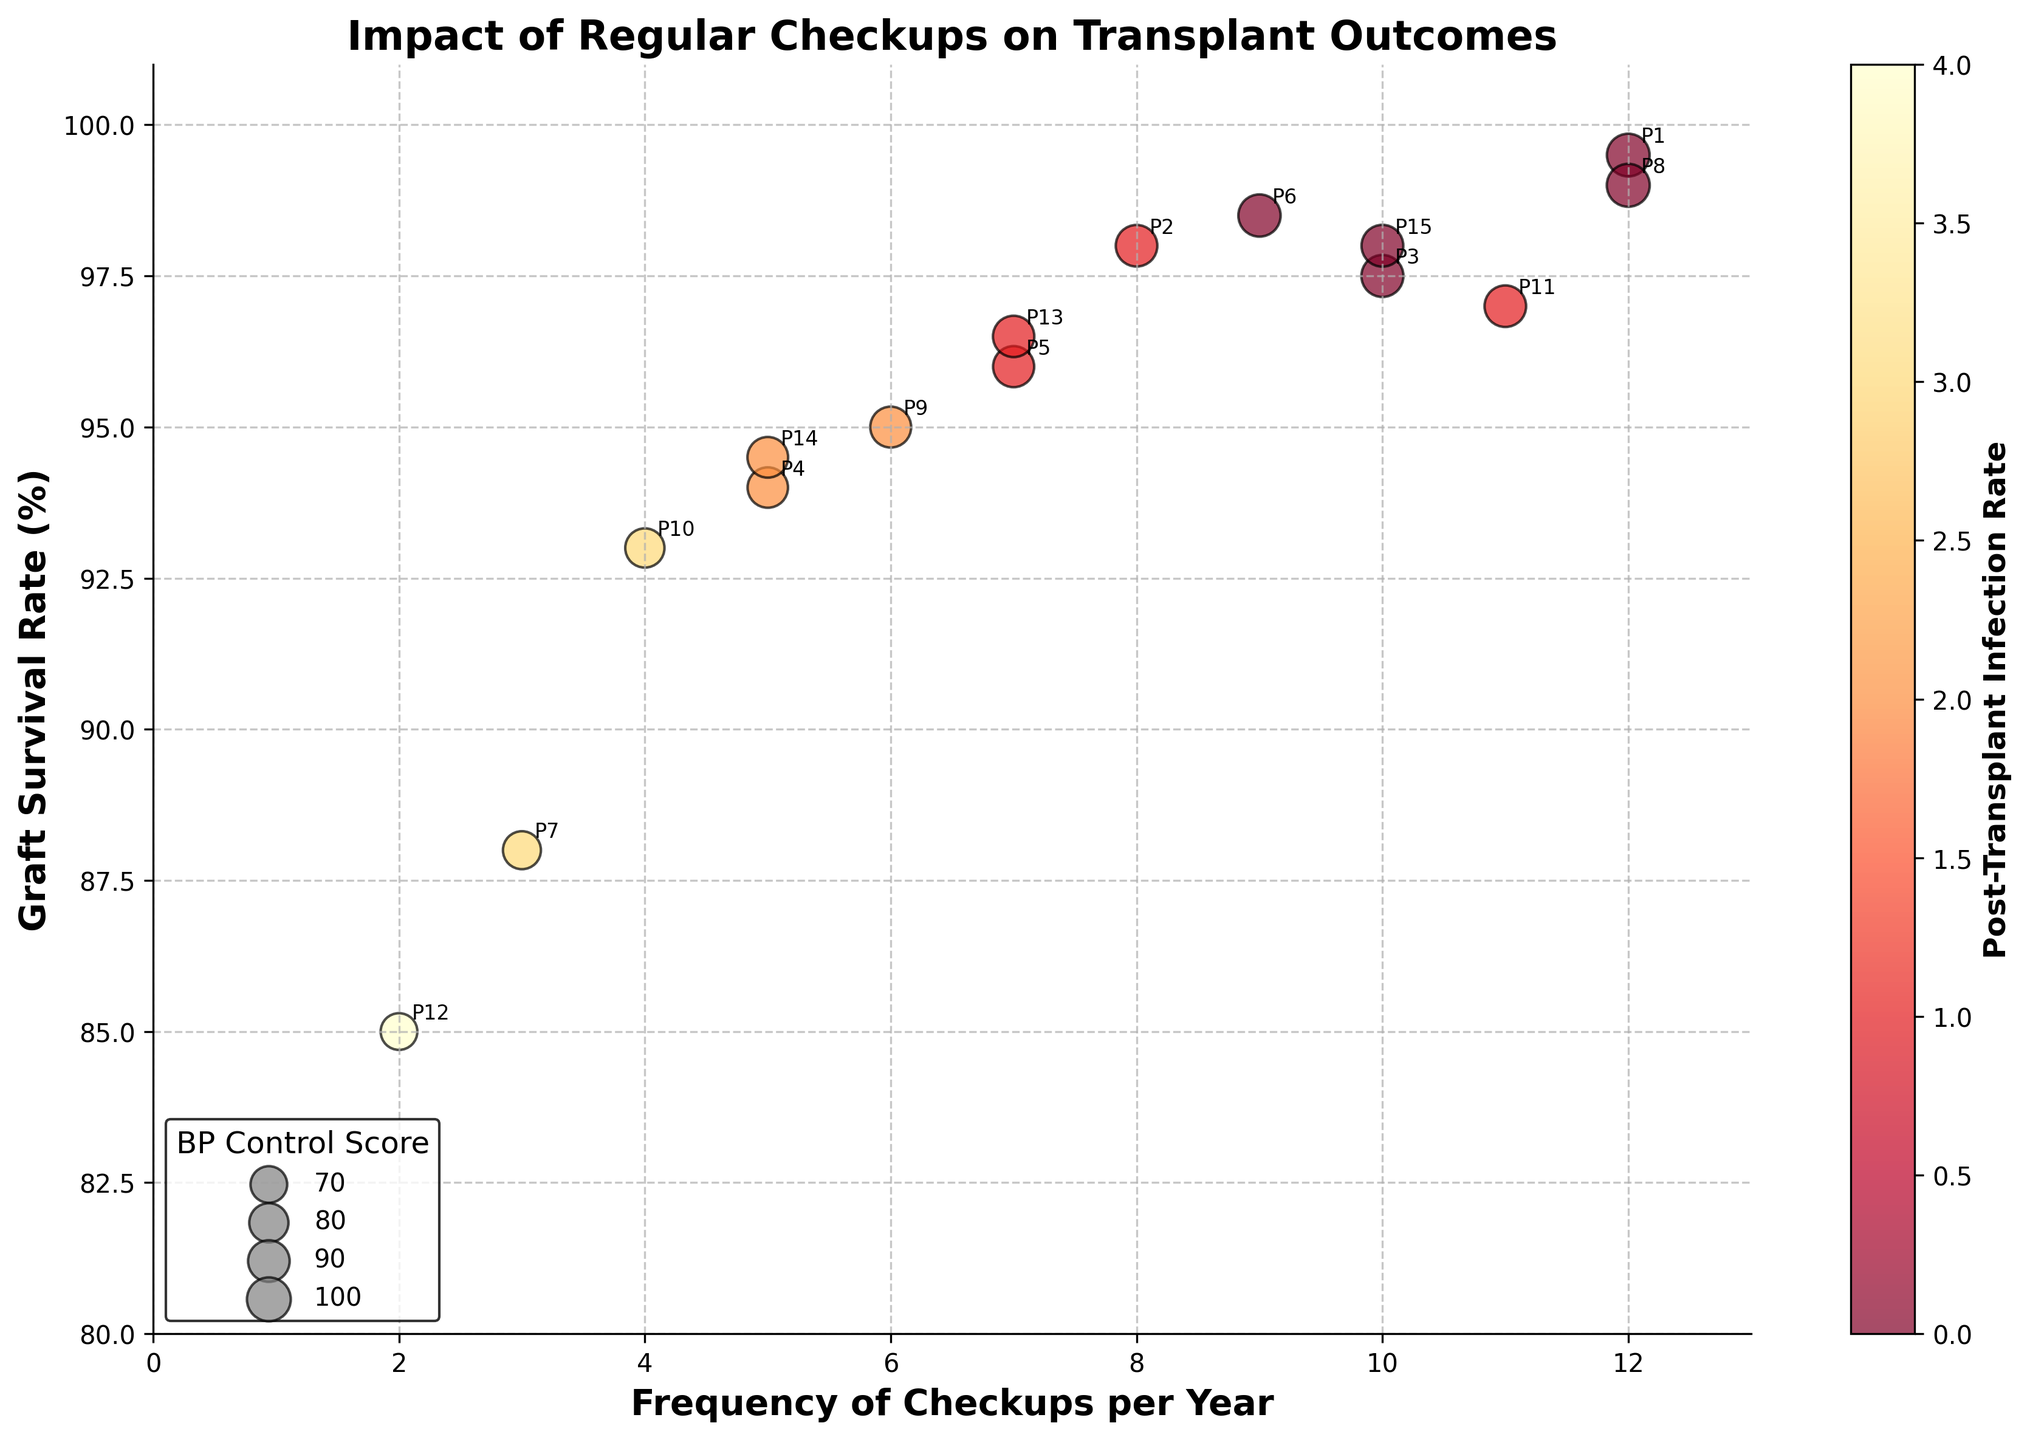What is the title of the figure? The title of the figure is displayed at the top of the plot. It summarizes the main objective or focus of the plot.
Answer: Impact of Regular Checkups on Transplant Outcomes How many data points represent patients who have a frequency of 12 checkups per year? Examine the x-axis values for 'Frequency of Checkups per Year' and count the number of points where this value is 12.
Answer: 2 Which patient has the lowest Graft Survival Rate, and what is their infection rate? Find the point with the lowest y-coordinate on the Graft Survival Rate axis and note the infection rate (color of the point).
Answer: Patient 12, infection rate = 4 What range of BP Control Scores is represented in the legend? Inspect the legend at the bottom-left of the plot, which maps BP Control Scores to the sizes of the scatter points.
Answer: 70 to 100 Which patient has the highest BP Control Score and their checkup frequency? Look for the largest scatter point and read off its 'Frequency of Checkups per Year' value.
Answer: Patient 8, frequency = 12 How many patients have had an infection rate of 0? Look at the scatter points with the color corresponding to an infection rate of 0 and count them.
Answer: 6 Is there a trend between the frequency of checkups and graft survival rates? Observe the overall distribution of points on the x and y axes to make an inference about possible trends.
Answer: Generally, higher checkups tend to correspond with higher survival rates What's the difference in Graft Survival Rate between patients with 12 and 2 checkups per year? Determine the Graft Survival Rate for both checkup frequencies and calculate the difference.
Answer: 99.5 - 85 = 14.5% Which patient has the best BP Control Score with less than 6 checkups per year? Filter for patients with checkups less than 6 and find the one with the highest BP Control Score.
Answer: Patient 9 What is the general relationship between post-transplant infection rate and BP Control Score? Analyze how the color intensity (representing the infection rate) correlates with the size of the points (BP Control Score).
Answer: Higher BP Control Scores often have lower infection rates 